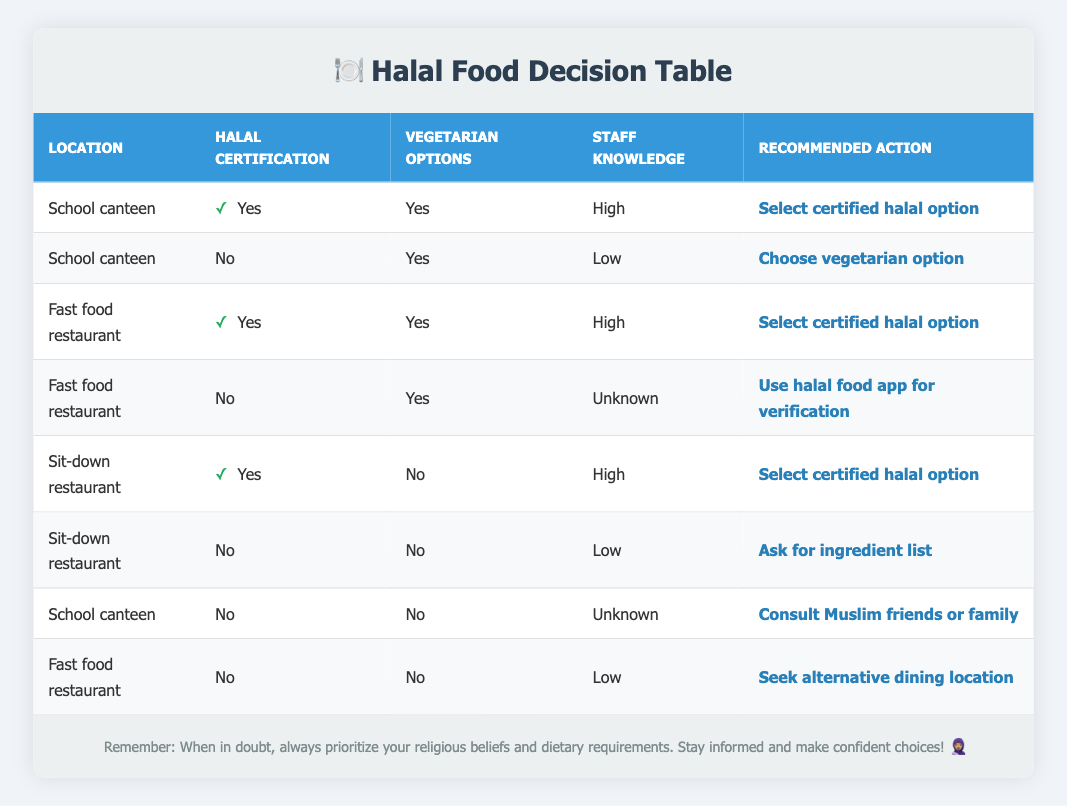What action should I take if I am at the school canteen and the halal certification is visible? In the table, under the conditions for "School canteen" with "Yes" for halal certification, the recommended action is to "Select certified halal option."
Answer: Select certified halal option If I am at a fast food restaurant without halal certification and with low staff knowledge, what should I do? According to the table, when at a fast food restaurant with "No" for halal certification and "Low" for staff knowledge, the recommended action is to "Seek alternative dining location."
Answer: Seek alternative dining location What is the action for a sit-down restaurant when there is no halal certification and no vegetarian options? The table shows that in the case of a sit-down restaurant with "No" for halal certification and "No" for vegetarian options, the suggested action is to "Ask for ingredient list."
Answer: Ask for ingredient list If there are vegetarian options available at a school canteen but no halal certification and low staff knowledge, can I still select a certified halal option? The table indicates that if there are vegetarian options but no halal certification and low staff knowledge, the recommended action is to "Choose vegetarian option," meaning I cannot select a certified halal option.
Answer: No What are the possible actions if I am at a sit-down restaurant with halal certification and high staff knowledge but no vegetarian options? Referring to the table, at a sit-down restaurant with "Yes" for halal certification, "High" staff knowledge, but "No" vegetarian options, the action remains to "Select certified halal option." Thus, the only action is to select a certified halal option.
Answer: Select certified halal option What would be the sequence of actions if I find myself in a school canteen with no halal certification, no vegetarian options, and unknown staff knowledge? Based on the table, with those conditions, the recommended action is to "Consult Muslim friends or family," so that would be the immediate action.
Answer: Consult Muslim friends or family If both certified halal options and vegetarian options are available at a fast food restaurant, what should I choose? The table states that when both "Yes" for halal certification and "Yes" for vegetarian options are present at a fast food restaurant, the action is to "Select certified halal option." Thus, the choice should prioritize the certified halal option.
Answer: Select certified halal option Is it more common to find certified halal options at fast food restaurants or sit-down restaurants, based on the table? The table shows that both types of restaurants offer certified halal options. For fast food restaurants, this applies when certification is "Yes," and similarly, sit-down restaurants can also provide this. Hence, it's a tie in terms of commonality for certified halal options between the two types.
Answer: Equal commonality 